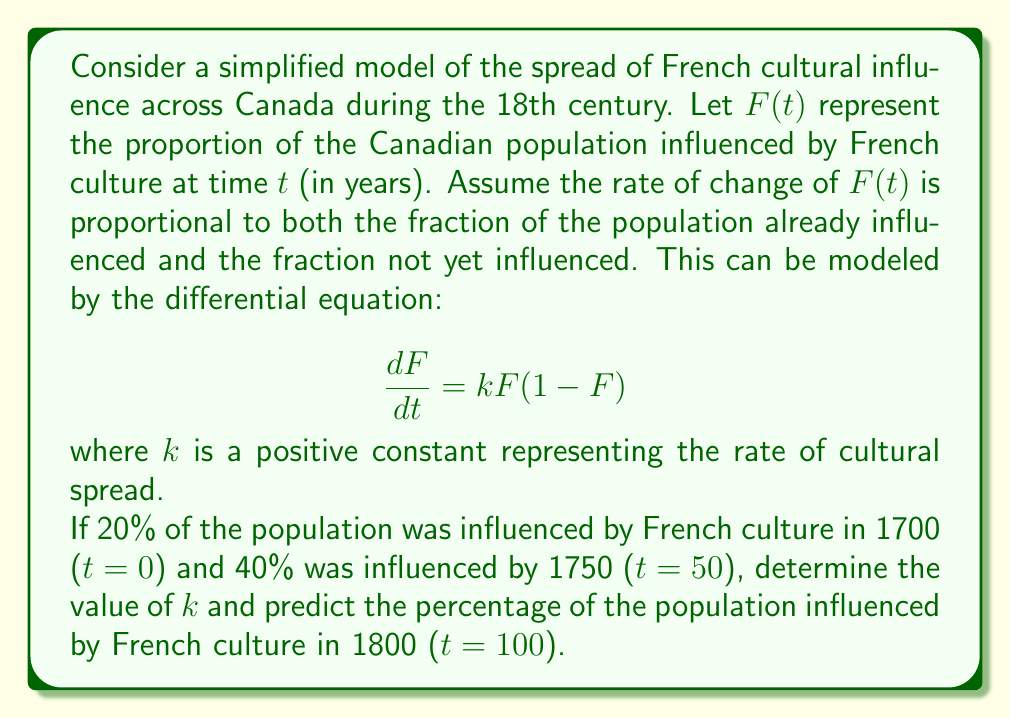Could you help me with this problem? To solve this problem, we'll follow these steps:

1) First, we need to solve the differential equation. The equation $$\frac{dF}{dt} = kF(1-F)$$ is a logistic differential equation.

2) The solution to this equation is:
   $$F(t) = \frac{1}{1 + Ce^{-kt}}$$
   where $C$ is a constant determined by the initial condition.

3) Given the initial condition F(0) = 0.2, we can find C:
   $$0.2 = \frac{1}{1 + C}$$
   $$C = 4$$

4) Now our solution is:
   $$F(t) = \frac{1}{1 + 4e^{-kt}}$$

5) We can use the second condition F(50) = 0.4 to find k:
   $$0.4 = \frac{1}{1 + 4e^{-50k}}$$

6) Solving this equation:
   $$1 + 4e^{-50k} = \frac{1}{0.4} = 2.5$$
   $$4e^{-50k} = 1.5$$
   $$e^{-50k} = 0.375$$
   $$-50k = \ln(0.375)$$
   $$k = -\frac{\ln(0.375)}{50} \approx 0.0196$$

7) Now that we have k, we can predict F(100):
   $$F(100) = \frac{1}{1 + 4e^{-0.0196 * 100}}$$
   $$= \frac{1}{1 + 4e^{-1.96}} \approx 0.6269$$

Therefore, the model predicts that approximately 62.69% of the population would be influenced by French culture by 1800.
Answer: $k \approx 0.0196$, and F(100) ≈ 0.6269 or 62.69% 